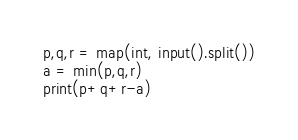Convert code to text. <code><loc_0><loc_0><loc_500><loc_500><_Python_>p,q,r = map(int, input().split())
a = min(p,q,r)
print(p+q+r-a)</code> 